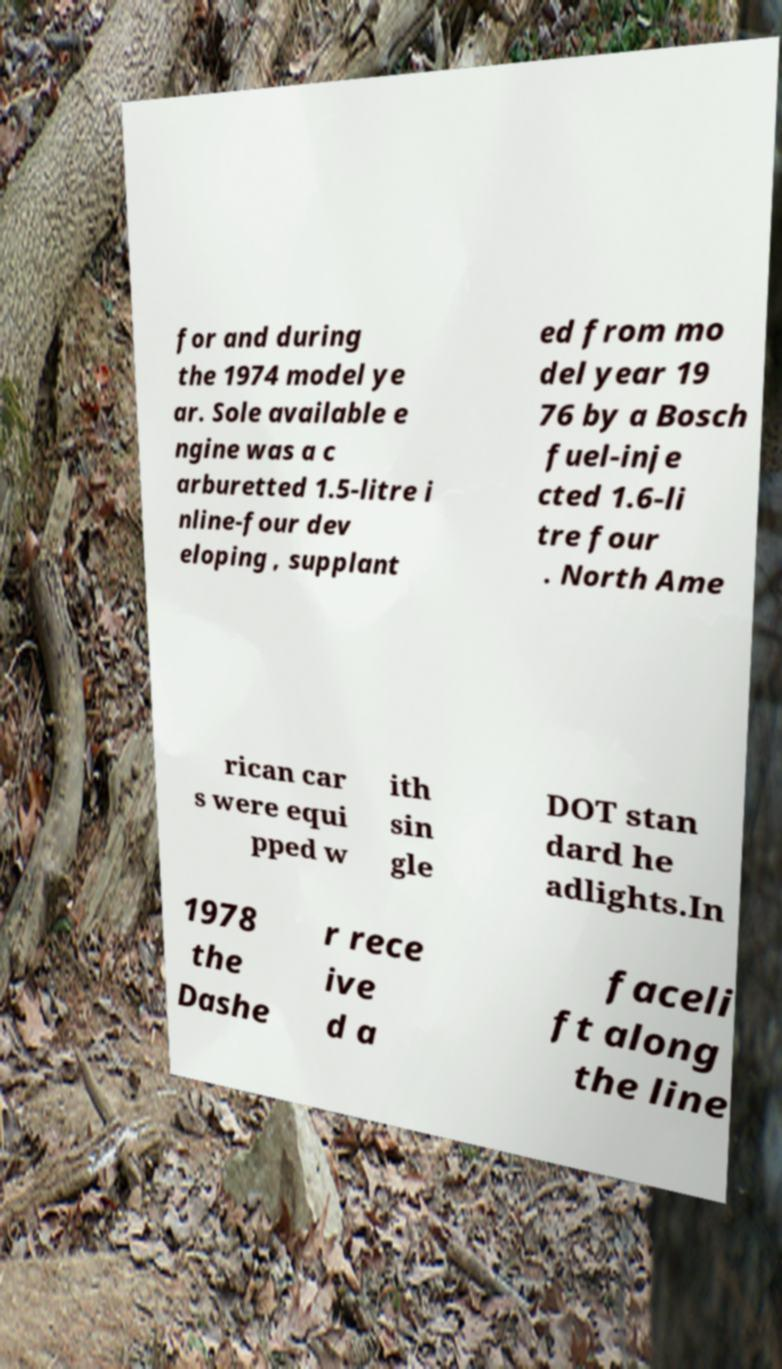Please identify and transcribe the text found in this image. for and during the 1974 model ye ar. Sole available e ngine was a c arburetted 1.5-litre i nline-four dev eloping , supplant ed from mo del year 19 76 by a Bosch fuel-inje cted 1.6-li tre four . North Ame rican car s were equi pped w ith sin gle DOT stan dard he adlights.In 1978 the Dashe r rece ive d a faceli ft along the line 